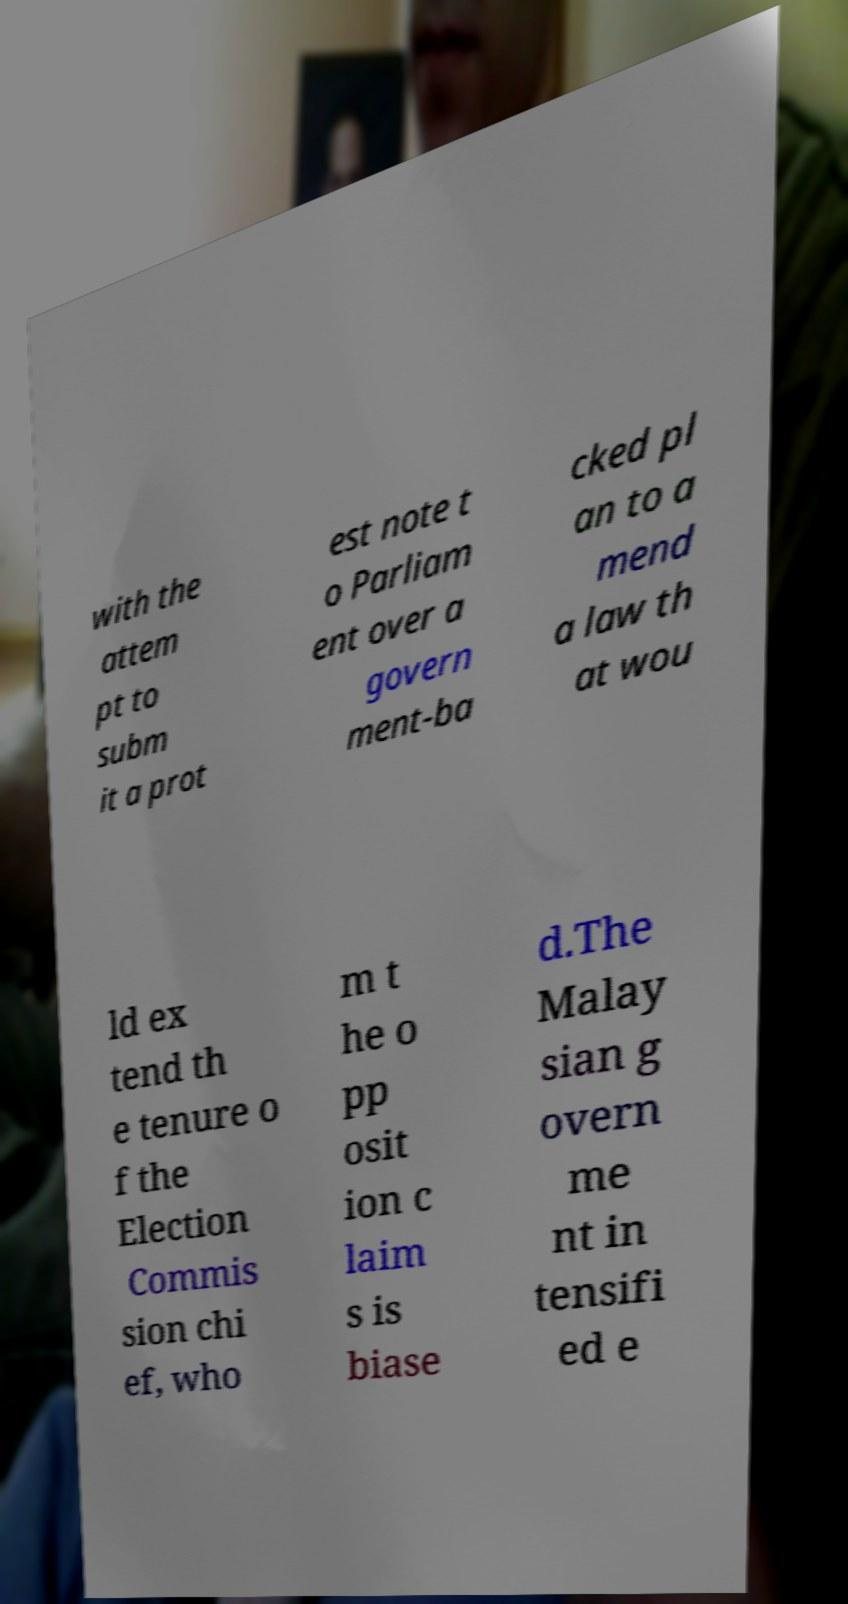What messages or text are displayed in this image? I need them in a readable, typed format. with the attem pt to subm it a prot est note t o Parliam ent over a govern ment-ba cked pl an to a mend a law th at wou ld ex tend th e tenure o f the Election Commis sion chi ef, who m t he o pp osit ion c laim s is biase d.The Malay sian g overn me nt in tensifi ed e 